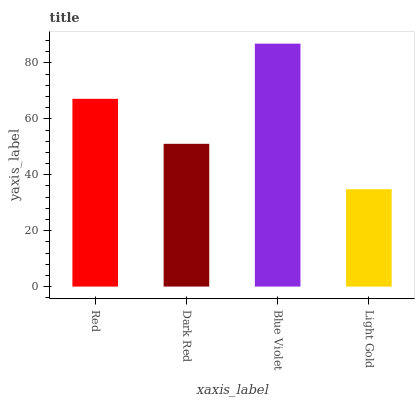Is Light Gold the minimum?
Answer yes or no. Yes. Is Blue Violet the maximum?
Answer yes or no. Yes. Is Dark Red the minimum?
Answer yes or no. No. Is Dark Red the maximum?
Answer yes or no. No. Is Red greater than Dark Red?
Answer yes or no. Yes. Is Dark Red less than Red?
Answer yes or no. Yes. Is Dark Red greater than Red?
Answer yes or no. No. Is Red less than Dark Red?
Answer yes or no. No. Is Red the high median?
Answer yes or no. Yes. Is Dark Red the low median?
Answer yes or no. Yes. Is Blue Violet the high median?
Answer yes or no. No. Is Blue Violet the low median?
Answer yes or no. No. 